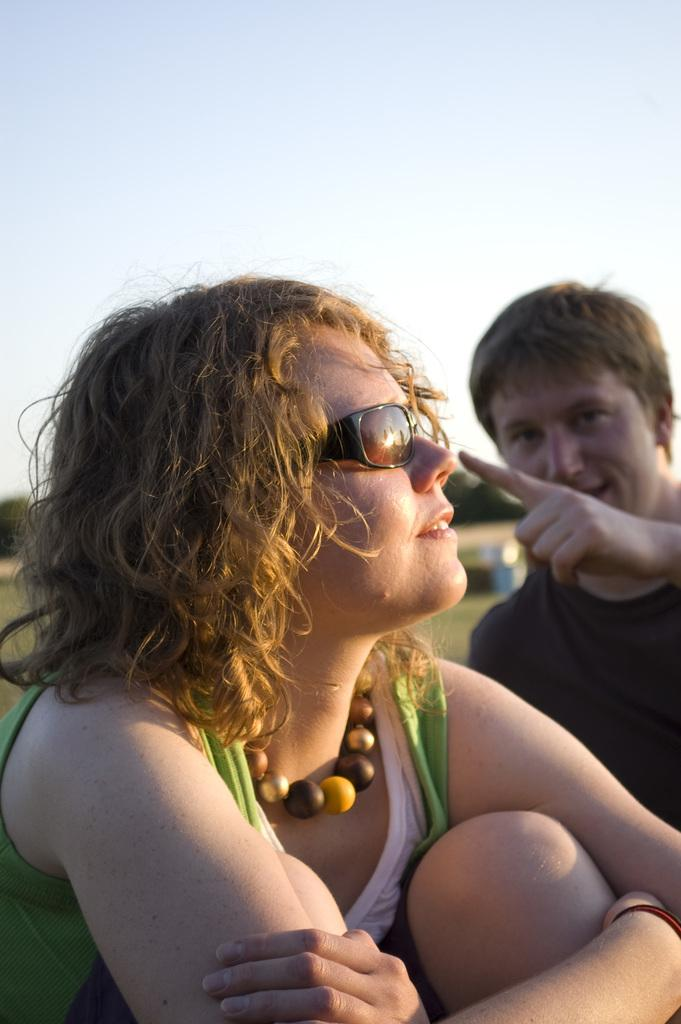How many people are present in the image? There are two people in the image. What type of ground surface can be seen in the image? There is grass in the image. What can be seen in the background of the image? There are trees in the background of the image. What type of salt is being used by the grandfather in the image? There is no grandfather or salt present in the image. 